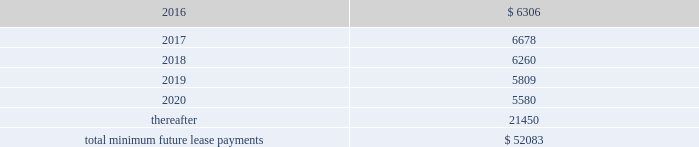Notes receivable in 2014 , we entered into a $ 3.0 million promissory note with a privately held company which was recorded at cost .
The interest rate on the promissory note is 8.0% ( 8.0 % ) per annum and is payable quarterly .
All unpaid principal and accrued interest on the promissory note is due and payable on the earlier of august 26 , 2017 , or upon default .
Commitments and contingencies operating leases we lease various operating spaces in north america , europe , asia and australia under non-cancelable operating lease arrangements that expire on various dates through 2024 .
These arrangements require us to pay certain operating expenses , such as taxes , repairs , and insurance and contain renewal and escalation clauses .
We recognize rent expense under these arrangements on a straight-line basis over the term of the lease .
As of december 31 , 2015 , the aggregate future minimum payments under non-cancelable operating leases consist of the following ( in thousands ) : years ending december 31 .
Rent expense for all operating leases amounted to $ 6.7 million , $ 3.3 million and $ 3.6 million for the years ended december 31 , 2015 , 2014 and 2013 , respectively .
Financing obligation 2014build-to-suit lease in august 2012 , we executed a lease for a building then under construction in santa clara , california to serve as our headquarters .
The lease term is 120 months and commenced in august 2013 .
Based on the terms of the lease agreement and due to our involvement in certain aspects of the construction such as our financial involvement in structural elements of asset construction , making decisions related to tenant improvement costs and purchasing insurance not reimbursable by the buyer-lessor ( the landlord ) , we were deemed the owner of the building ( for accounting purposes only ) during the construction period .
We continue to maintain involvement in the property post construction completion and lack transferability of the risks and rewards of ownership , due to our required maintenance of a $ 4.0 million letter of credit , in addition to our ability and option to sublease our portion of the leased building for fees substantially higher than our base rate .
Due to our continued involvement in the property and lack of transferability of related risks and rewards of ownership to the landlord post construction , we account for the building and related improvements as a lease financing obligation .
Accordingly , as of december 31 , 2015 and 2014 , we have recorded assets of $ 53.4 million , representing the total costs of the building and improvements incurred , including the costs paid by the lessor ( the legal owner of the building ) and additional improvement costs paid by us , and a corresponding financing obligation of $ 42.5 million and $ 43.6 million , respectively .
As of december 31 , 2015 , $ 1.3 million and $ 41.2 million were recorded as short-term and long-term financing obligations , respectively .
Land lease expense under our lease financing obligation included in rent expense above , amounted to $ 1.3 million and $ 1.2 million for the years ended december 31 , 2015 and 2014 , respectively .
There was no land lease expense for the year ended december 31 , 2013. .
As of december 31 , 2015 what was the 2016 percent of non-cancelable operating leases as part of the total minimum future lease payments? 
Computations: (6306 / 52083)
Answer: 0.12108. 